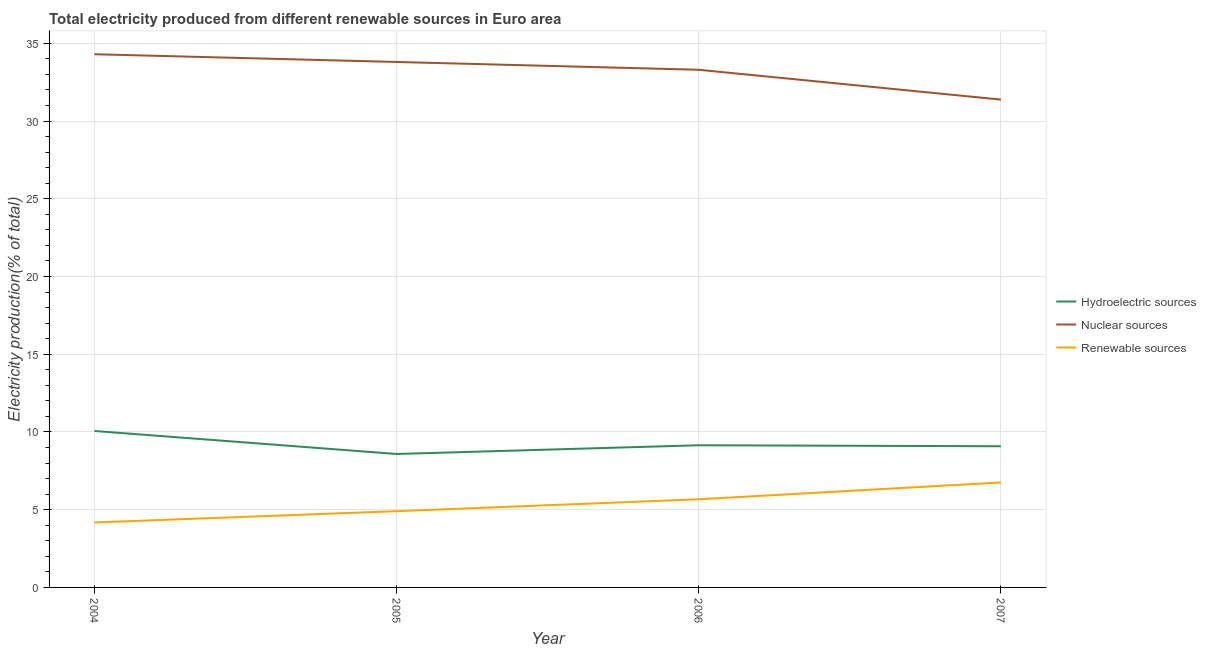Does the line corresponding to percentage of electricity produced by nuclear sources intersect with the line corresponding to percentage of electricity produced by renewable sources?
Offer a very short reply. No. Is the number of lines equal to the number of legend labels?
Your answer should be very brief. Yes. What is the percentage of electricity produced by hydroelectric sources in 2006?
Give a very brief answer. 9.14. Across all years, what is the maximum percentage of electricity produced by renewable sources?
Offer a terse response. 6.75. Across all years, what is the minimum percentage of electricity produced by nuclear sources?
Offer a very short reply. 31.38. In which year was the percentage of electricity produced by hydroelectric sources maximum?
Offer a terse response. 2004. What is the total percentage of electricity produced by renewable sources in the graph?
Your answer should be compact. 21.51. What is the difference between the percentage of electricity produced by hydroelectric sources in 2004 and that in 2006?
Offer a very short reply. 0.92. What is the difference between the percentage of electricity produced by renewable sources in 2007 and the percentage of electricity produced by hydroelectric sources in 2004?
Give a very brief answer. -3.31. What is the average percentage of electricity produced by hydroelectric sources per year?
Offer a very short reply. 9.22. In the year 2004, what is the difference between the percentage of electricity produced by hydroelectric sources and percentage of electricity produced by nuclear sources?
Ensure brevity in your answer.  -24.23. In how many years, is the percentage of electricity produced by nuclear sources greater than 34 %?
Make the answer very short. 1. What is the ratio of the percentage of electricity produced by hydroelectric sources in 2004 to that in 2006?
Ensure brevity in your answer.  1.1. Is the percentage of electricity produced by hydroelectric sources in 2006 less than that in 2007?
Offer a terse response. No. What is the difference between the highest and the second highest percentage of electricity produced by nuclear sources?
Provide a short and direct response. 0.5. What is the difference between the highest and the lowest percentage of electricity produced by renewable sources?
Give a very brief answer. 2.57. In how many years, is the percentage of electricity produced by hydroelectric sources greater than the average percentage of electricity produced by hydroelectric sources taken over all years?
Provide a succinct answer. 1. Is the percentage of electricity produced by nuclear sources strictly greater than the percentage of electricity produced by hydroelectric sources over the years?
Your answer should be very brief. Yes. Is the percentage of electricity produced by renewable sources strictly less than the percentage of electricity produced by hydroelectric sources over the years?
Make the answer very short. Yes. How many years are there in the graph?
Ensure brevity in your answer.  4. Are the values on the major ticks of Y-axis written in scientific E-notation?
Offer a terse response. No. Does the graph contain any zero values?
Your response must be concise. No. What is the title of the graph?
Keep it short and to the point. Total electricity produced from different renewable sources in Euro area. What is the Electricity production(% of total) of Hydroelectric sources in 2004?
Your response must be concise. 10.06. What is the Electricity production(% of total) of Nuclear sources in 2004?
Offer a very short reply. 34.3. What is the Electricity production(% of total) in Renewable sources in 2004?
Make the answer very short. 4.18. What is the Electricity production(% of total) of Hydroelectric sources in 2005?
Ensure brevity in your answer.  8.58. What is the Electricity production(% of total) of Nuclear sources in 2005?
Ensure brevity in your answer.  33.8. What is the Electricity production(% of total) in Renewable sources in 2005?
Provide a succinct answer. 4.91. What is the Electricity production(% of total) in Hydroelectric sources in 2006?
Your response must be concise. 9.14. What is the Electricity production(% of total) in Nuclear sources in 2006?
Give a very brief answer. 33.3. What is the Electricity production(% of total) in Renewable sources in 2006?
Your response must be concise. 5.67. What is the Electricity production(% of total) of Hydroelectric sources in 2007?
Offer a terse response. 9.08. What is the Electricity production(% of total) in Nuclear sources in 2007?
Offer a very short reply. 31.38. What is the Electricity production(% of total) of Renewable sources in 2007?
Offer a very short reply. 6.75. Across all years, what is the maximum Electricity production(% of total) in Hydroelectric sources?
Your response must be concise. 10.06. Across all years, what is the maximum Electricity production(% of total) of Nuclear sources?
Provide a succinct answer. 34.3. Across all years, what is the maximum Electricity production(% of total) in Renewable sources?
Your response must be concise. 6.75. Across all years, what is the minimum Electricity production(% of total) in Hydroelectric sources?
Your answer should be very brief. 8.58. Across all years, what is the minimum Electricity production(% of total) of Nuclear sources?
Give a very brief answer. 31.38. Across all years, what is the minimum Electricity production(% of total) in Renewable sources?
Your answer should be compact. 4.18. What is the total Electricity production(% of total) in Hydroelectric sources in the graph?
Offer a very short reply. 36.87. What is the total Electricity production(% of total) in Nuclear sources in the graph?
Offer a terse response. 132.77. What is the total Electricity production(% of total) in Renewable sources in the graph?
Your answer should be compact. 21.51. What is the difference between the Electricity production(% of total) of Hydroelectric sources in 2004 and that in 2005?
Give a very brief answer. 1.48. What is the difference between the Electricity production(% of total) of Nuclear sources in 2004 and that in 2005?
Your answer should be very brief. 0.5. What is the difference between the Electricity production(% of total) in Renewable sources in 2004 and that in 2005?
Offer a very short reply. -0.73. What is the difference between the Electricity production(% of total) of Hydroelectric sources in 2004 and that in 2006?
Your answer should be compact. 0.92. What is the difference between the Electricity production(% of total) in Renewable sources in 2004 and that in 2006?
Offer a very short reply. -1.49. What is the difference between the Electricity production(% of total) of Hydroelectric sources in 2004 and that in 2007?
Ensure brevity in your answer.  0.98. What is the difference between the Electricity production(% of total) of Nuclear sources in 2004 and that in 2007?
Make the answer very short. 2.92. What is the difference between the Electricity production(% of total) in Renewable sources in 2004 and that in 2007?
Give a very brief answer. -2.57. What is the difference between the Electricity production(% of total) in Hydroelectric sources in 2005 and that in 2006?
Make the answer very short. -0.56. What is the difference between the Electricity production(% of total) in Nuclear sources in 2005 and that in 2006?
Offer a terse response. 0.5. What is the difference between the Electricity production(% of total) in Renewable sources in 2005 and that in 2006?
Keep it short and to the point. -0.76. What is the difference between the Electricity production(% of total) of Hydroelectric sources in 2005 and that in 2007?
Offer a very short reply. -0.5. What is the difference between the Electricity production(% of total) in Nuclear sources in 2005 and that in 2007?
Make the answer very short. 2.42. What is the difference between the Electricity production(% of total) of Renewable sources in 2005 and that in 2007?
Keep it short and to the point. -1.85. What is the difference between the Electricity production(% of total) in Hydroelectric sources in 2006 and that in 2007?
Your answer should be very brief. 0.06. What is the difference between the Electricity production(% of total) of Nuclear sources in 2006 and that in 2007?
Give a very brief answer. 1.92. What is the difference between the Electricity production(% of total) of Renewable sources in 2006 and that in 2007?
Your answer should be very brief. -1.08. What is the difference between the Electricity production(% of total) of Hydroelectric sources in 2004 and the Electricity production(% of total) of Nuclear sources in 2005?
Provide a succinct answer. -23.74. What is the difference between the Electricity production(% of total) in Hydroelectric sources in 2004 and the Electricity production(% of total) in Renewable sources in 2005?
Your response must be concise. 5.16. What is the difference between the Electricity production(% of total) of Nuclear sources in 2004 and the Electricity production(% of total) of Renewable sources in 2005?
Your answer should be very brief. 29.39. What is the difference between the Electricity production(% of total) in Hydroelectric sources in 2004 and the Electricity production(% of total) in Nuclear sources in 2006?
Ensure brevity in your answer.  -23.23. What is the difference between the Electricity production(% of total) in Hydroelectric sources in 2004 and the Electricity production(% of total) in Renewable sources in 2006?
Keep it short and to the point. 4.39. What is the difference between the Electricity production(% of total) of Nuclear sources in 2004 and the Electricity production(% of total) of Renewable sources in 2006?
Make the answer very short. 28.63. What is the difference between the Electricity production(% of total) in Hydroelectric sources in 2004 and the Electricity production(% of total) in Nuclear sources in 2007?
Provide a short and direct response. -21.32. What is the difference between the Electricity production(% of total) of Hydroelectric sources in 2004 and the Electricity production(% of total) of Renewable sources in 2007?
Provide a succinct answer. 3.31. What is the difference between the Electricity production(% of total) of Nuclear sources in 2004 and the Electricity production(% of total) of Renewable sources in 2007?
Make the answer very short. 27.54. What is the difference between the Electricity production(% of total) in Hydroelectric sources in 2005 and the Electricity production(% of total) in Nuclear sources in 2006?
Your answer should be compact. -24.71. What is the difference between the Electricity production(% of total) of Hydroelectric sources in 2005 and the Electricity production(% of total) of Renewable sources in 2006?
Your answer should be compact. 2.91. What is the difference between the Electricity production(% of total) of Nuclear sources in 2005 and the Electricity production(% of total) of Renewable sources in 2006?
Ensure brevity in your answer.  28.13. What is the difference between the Electricity production(% of total) in Hydroelectric sources in 2005 and the Electricity production(% of total) in Nuclear sources in 2007?
Your response must be concise. -22.8. What is the difference between the Electricity production(% of total) in Hydroelectric sources in 2005 and the Electricity production(% of total) in Renewable sources in 2007?
Offer a very short reply. 1.83. What is the difference between the Electricity production(% of total) of Nuclear sources in 2005 and the Electricity production(% of total) of Renewable sources in 2007?
Provide a succinct answer. 27.05. What is the difference between the Electricity production(% of total) of Hydroelectric sources in 2006 and the Electricity production(% of total) of Nuclear sources in 2007?
Make the answer very short. -22.23. What is the difference between the Electricity production(% of total) of Hydroelectric sources in 2006 and the Electricity production(% of total) of Renewable sources in 2007?
Keep it short and to the point. 2.39. What is the difference between the Electricity production(% of total) of Nuclear sources in 2006 and the Electricity production(% of total) of Renewable sources in 2007?
Offer a terse response. 26.55. What is the average Electricity production(% of total) of Hydroelectric sources per year?
Ensure brevity in your answer.  9.22. What is the average Electricity production(% of total) of Nuclear sources per year?
Offer a terse response. 33.19. What is the average Electricity production(% of total) in Renewable sources per year?
Make the answer very short. 5.38. In the year 2004, what is the difference between the Electricity production(% of total) in Hydroelectric sources and Electricity production(% of total) in Nuclear sources?
Make the answer very short. -24.23. In the year 2004, what is the difference between the Electricity production(% of total) in Hydroelectric sources and Electricity production(% of total) in Renewable sources?
Your answer should be compact. 5.88. In the year 2004, what is the difference between the Electricity production(% of total) in Nuclear sources and Electricity production(% of total) in Renewable sources?
Your answer should be compact. 30.12. In the year 2005, what is the difference between the Electricity production(% of total) of Hydroelectric sources and Electricity production(% of total) of Nuclear sources?
Ensure brevity in your answer.  -25.22. In the year 2005, what is the difference between the Electricity production(% of total) in Hydroelectric sources and Electricity production(% of total) in Renewable sources?
Ensure brevity in your answer.  3.68. In the year 2005, what is the difference between the Electricity production(% of total) of Nuclear sources and Electricity production(% of total) of Renewable sources?
Provide a short and direct response. 28.89. In the year 2006, what is the difference between the Electricity production(% of total) in Hydroelectric sources and Electricity production(% of total) in Nuclear sources?
Make the answer very short. -24.15. In the year 2006, what is the difference between the Electricity production(% of total) of Hydroelectric sources and Electricity production(% of total) of Renewable sources?
Offer a terse response. 3.47. In the year 2006, what is the difference between the Electricity production(% of total) in Nuclear sources and Electricity production(% of total) in Renewable sources?
Your response must be concise. 27.63. In the year 2007, what is the difference between the Electricity production(% of total) of Hydroelectric sources and Electricity production(% of total) of Nuclear sources?
Your answer should be very brief. -22.3. In the year 2007, what is the difference between the Electricity production(% of total) of Hydroelectric sources and Electricity production(% of total) of Renewable sources?
Ensure brevity in your answer.  2.33. In the year 2007, what is the difference between the Electricity production(% of total) in Nuclear sources and Electricity production(% of total) in Renewable sources?
Your answer should be compact. 24.63. What is the ratio of the Electricity production(% of total) of Hydroelectric sources in 2004 to that in 2005?
Offer a terse response. 1.17. What is the ratio of the Electricity production(% of total) in Nuclear sources in 2004 to that in 2005?
Offer a terse response. 1.01. What is the ratio of the Electricity production(% of total) of Renewable sources in 2004 to that in 2005?
Your answer should be compact. 0.85. What is the ratio of the Electricity production(% of total) in Hydroelectric sources in 2004 to that in 2006?
Provide a short and direct response. 1.1. What is the ratio of the Electricity production(% of total) in Renewable sources in 2004 to that in 2006?
Your response must be concise. 0.74. What is the ratio of the Electricity production(% of total) in Hydroelectric sources in 2004 to that in 2007?
Offer a terse response. 1.11. What is the ratio of the Electricity production(% of total) of Nuclear sources in 2004 to that in 2007?
Keep it short and to the point. 1.09. What is the ratio of the Electricity production(% of total) in Renewable sources in 2004 to that in 2007?
Offer a terse response. 0.62. What is the ratio of the Electricity production(% of total) in Hydroelectric sources in 2005 to that in 2006?
Your response must be concise. 0.94. What is the ratio of the Electricity production(% of total) of Nuclear sources in 2005 to that in 2006?
Your answer should be very brief. 1.02. What is the ratio of the Electricity production(% of total) in Renewable sources in 2005 to that in 2006?
Provide a succinct answer. 0.87. What is the ratio of the Electricity production(% of total) of Hydroelectric sources in 2005 to that in 2007?
Your response must be concise. 0.95. What is the ratio of the Electricity production(% of total) in Nuclear sources in 2005 to that in 2007?
Ensure brevity in your answer.  1.08. What is the ratio of the Electricity production(% of total) of Renewable sources in 2005 to that in 2007?
Make the answer very short. 0.73. What is the ratio of the Electricity production(% of total) in Hydroelectric sources in 2006 to that in 2007?
Ensure brevity in your answer.  1.01. What is the ratio of the Electricity production(% of total) of Nuclear sources in 2006 to that in 2007?
Offer a terse response. 1.06. What is the ratio of the Electricity production(% of total) in Renewable sources in 2006 to that in 2007?
Provide a succinct answer. 0.84. What is the difference between the highest and the second highest Electricity production(% of total) of Hydroelectric sources?
Give a very brief answer. 0.92. What is the difference between the highest and the second highest Electricity production(% of total) of Nuclear sources?
Provide a short and direct response. 0.5. What is the difference between the highest and the second highest Electricity production(% of total) of Renewable sources?
Your answer should be very brief. 1.08. What is the difference between the highest and the lowest Electricity production(% of total) in Hydroelectric sources?
Ensure brevity in your answer.  1.48. What is the difference between the highest and the lowest Electricity production(% of total) in Nuclear sources?
Give a very brief answer. 2.92. What is the difference between the highest and the lowest Electricity production(% of total) in Renewable sources?
Provide a short and direct response. 2.57. 